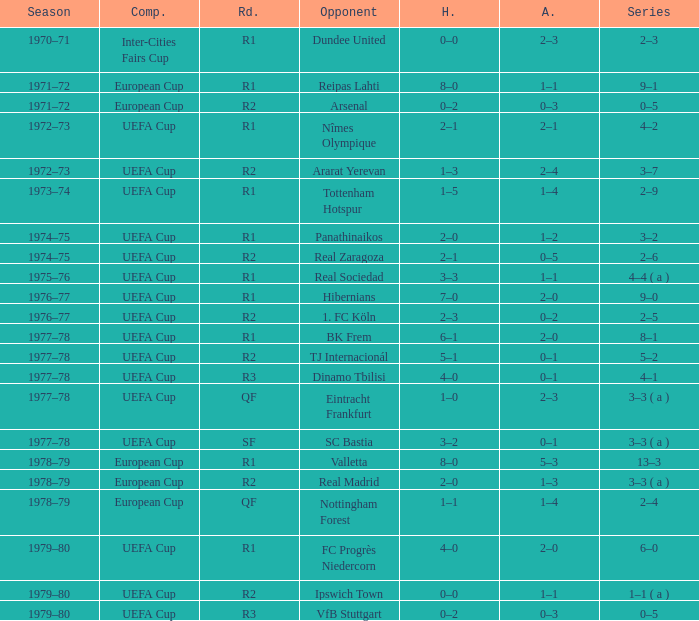Which home features a european cup contest and a quarter-final stage? 1–1. 